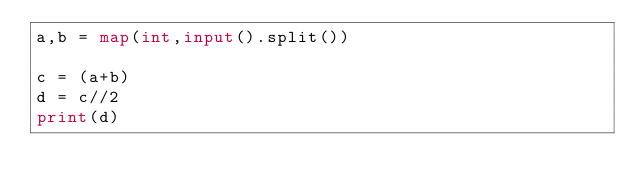<code> <loc_0><loc_0><loc_500><loc_500><_Python_>a,b = map(int,input().split())

c = (a+b)
d = c//2
print(d)

</code> 